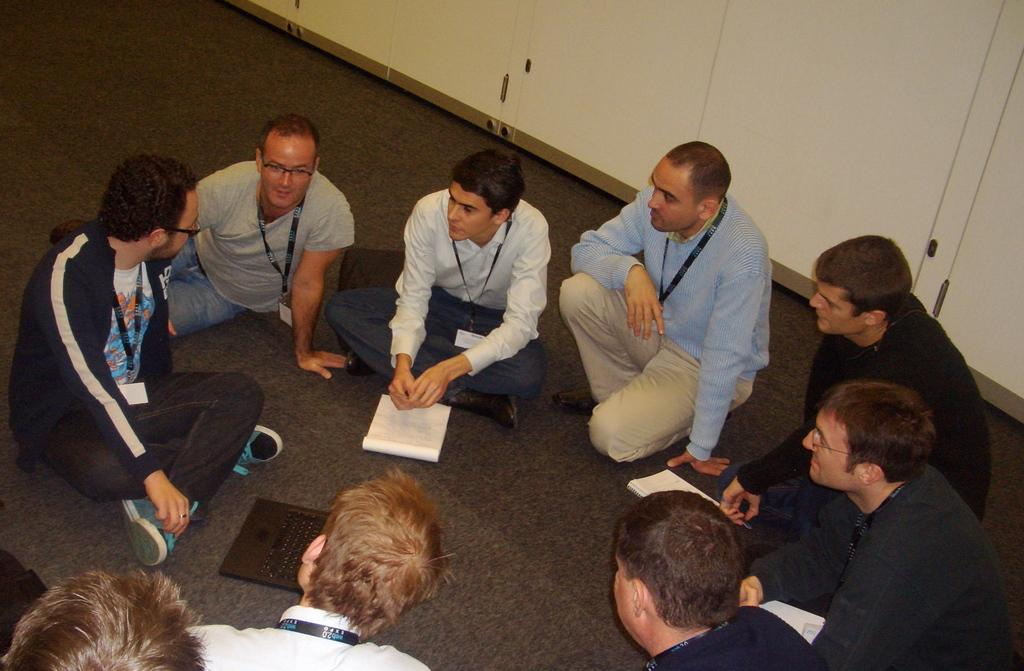What are the boys doing in the image? The boys are sitting on the flooring mat and discussing something. What can be seen behind the boys? There is a white color wardrobe behind them. What type of flesh can be seen on the boys' hands in the image? There is no flesh visible on the boys' hands in the image, and the term "flesh" is not relevant to the image. 